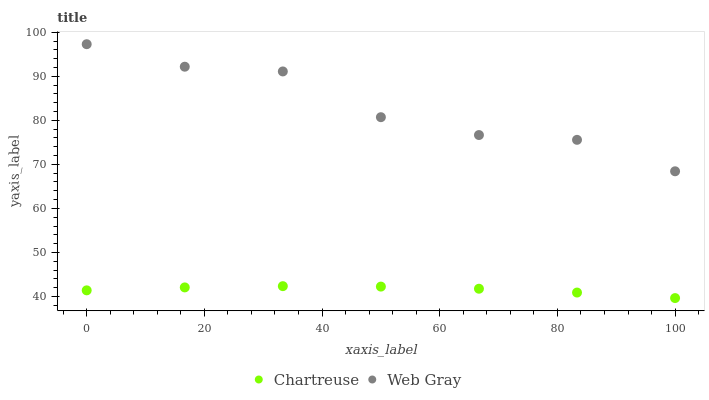Does Chartreuse have the minimum area under the curve?
Answer yes or no. Yes. Does Web Gray have the maximum area under the curve?
Answer yes or no. Yes. Does Web Gray have the minimum area under the curve?
Answer yes or no. No. Is Chartreuse the smoothest?
Answer yes or no. Yes. Is Web Gray the roughest?
Answer yes or no. Yes. Is Web Gray the smoothest?
Answer yes or no. No. Does Chartreuse have the lowest value?
Answer yes or no. Yes. Does Web Gray have the lowest value?
Answer yes or no. No. Does Web Gray have the highest value?
Answer yes or no. Yes. Is Chartreuse less than Web Gray?
Answer yes or no. Yes. Is Web Gray greater than Chartreuse?
Answer yes or no. Yes. Does Chartreuse intersect Web Gray?
Answer yes or no. No. 